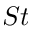Convert formula to latex. <formula><loc_0><loc_0><loc_500><loc_500>S t</formula> 